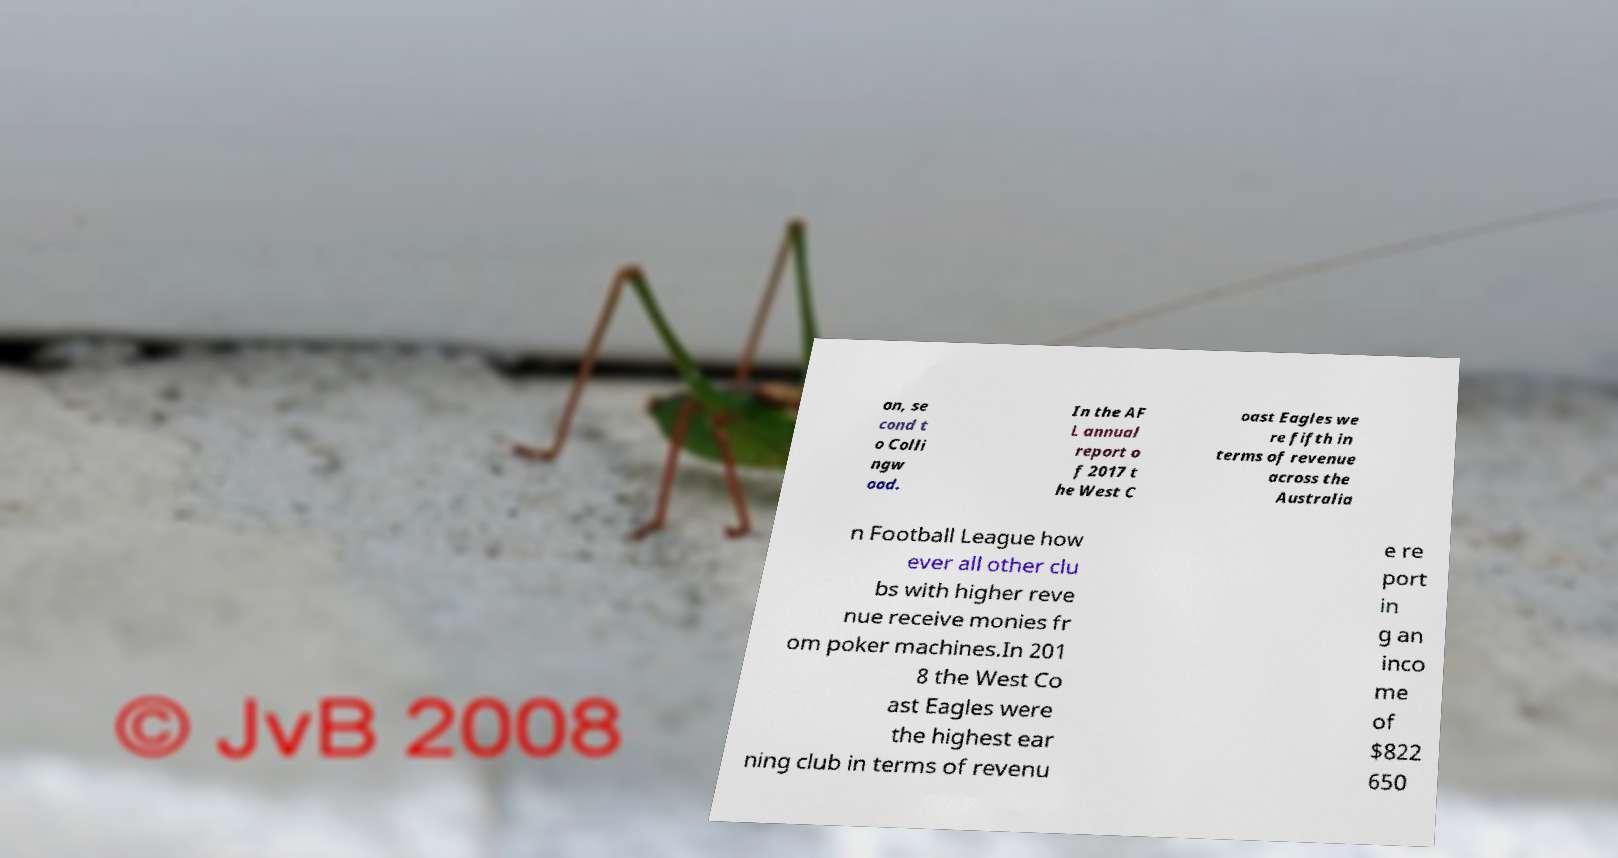Can you read and provide the text displayed in the image?This photo seems to have some interesting text. Can you extract and type it out for me? on, se cond t o Colli ngw ood. In the AF L annual report o f 2017 t he West C oast Eagles we re fifth in terms of revenue across the Australia n Football League how ever all other clu bs with higher reve nue receive monies fr om poker machines.In 201 8 the West Co ast Eagles were the highest ear ning club in terms of revenu e re port in g an inco me of $822 650 